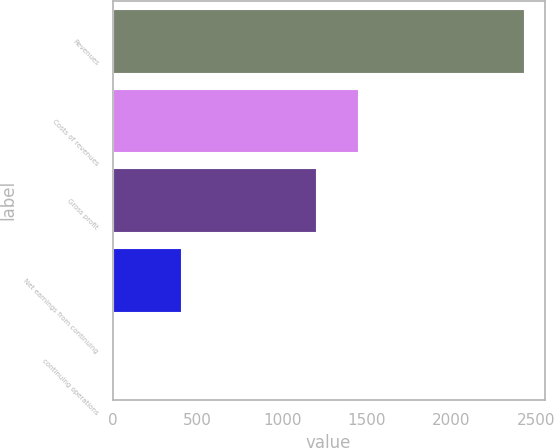<chart> <loc_0><loc_0><loc_500><loc_500><bar_chart><fcel>Revenues<fcel>Costs of revenues<fcel>Gross profit<fcel>Net earnings from continuing<fcel>continuing operations<nl><fcel>2427.2<fcel>1445.44<fcel>1202.8<fcel>403.6<fcel>0.78<nl></chart> 